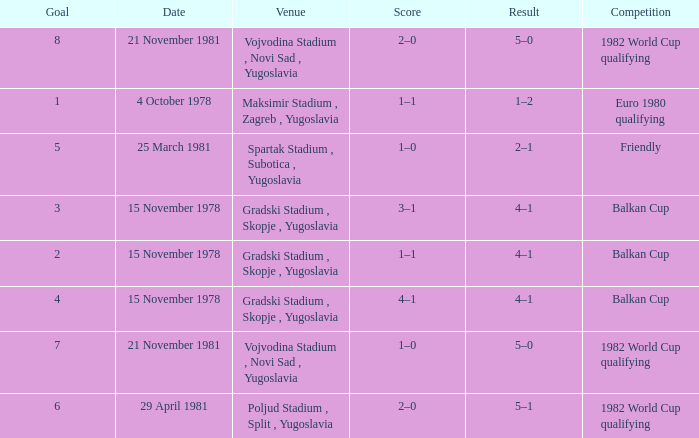What is the Result for Goal 3? 4–1. 